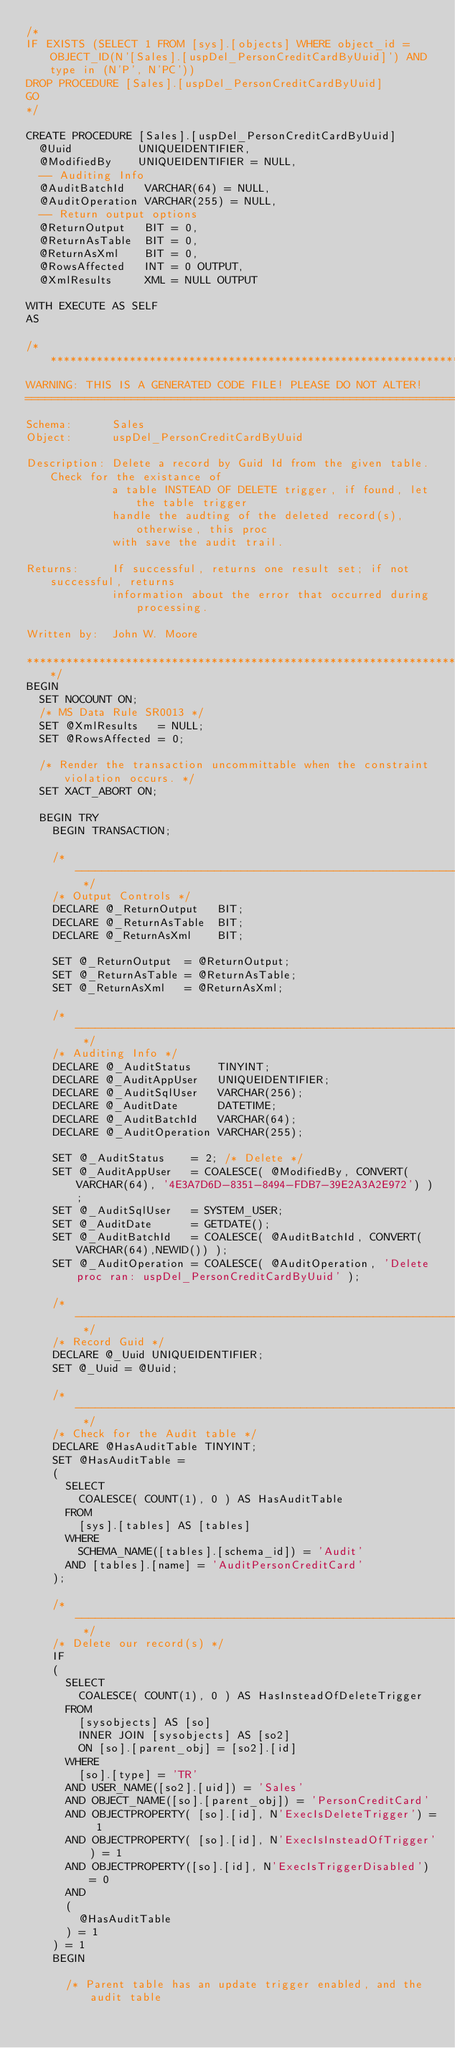<code> <loc_0><loc_0><loc_500><loc_500><_SQL_>/*
IF EXISTS (SELECT 1 FROM [sys].[objects] WHERE object_id = OBJECT_ID(N'[Sales].[uspDel_PersonCreditCardByUuid]') AND type in (N'P', N'PC'))
DROP PROCEDURE [Sales].[uspDel_PersonCreditCardByUuid]
GO
*/

CREATE PROCEDURE [Sales].[uspDel_PersonCreditCardByUuid]
  @Uuid          UNIQUEIDENTIFIER,
  @ModifiedBy    UNIQUEIDENTIFIER = NULL,
  -- Auditing Info
  @AuditBatchId   VARCHAR(64) = NULL,
  @AuditOperation VARCHAR(255) = NULL,
  -- Return output options
  @ReturnOutput   BIT = 0,
  @ReturnAsTable  BIT = 0,
  @ReturnAsXml    BIT = 0,
  @RowsAffected   INT = 0 OUTPUT,
  @XmlResults     XML = NULL OUTPUT

WITH EXECUTE AS SELF
AS

/*******************************************************************************
WARNING: THIS IS A GENERATED CODE FILE! PLEASE DO NOT ALTER!
================================================================================
Schema:      Sales
Object:      uspDel_PersonCreditCardByUuid

Description: Delete a record by Guid Id from the given table. Check for the existance of
             a table INSTEAD OF DELETE trigger, if found, let the table trigger
             handle the audting of the deleted record(s), otherwise, this proc
             with save the audit trail.

Returns:     If successful, returns one result set; if not successful, returns
             information about the error that occurred during processing.

Written by:  John W. Moore

*******************************************************************************/
BEGIN
  SET NOCOUNT ON;
  /* MS Data Rule SR0013 */
  SET @XmlResults   = NULL;
  SET @RowsAffected = 0;

  /* Render the transaction uncommittable when the constraint violation occurs. */
  SET XACT_ABORT ON;

  BEGIN TRY
    BEGIN TRANSACTION;

    /* ------------------------------------------------------------------------- */
    /* Output Controls */
    DECLARE @_ReturnOutput   BIT;
    DECLARE @_ReturnAsTable  BIT;
    DECLARE @_ReturnAsXml    BIT;

    SET @_ReturnOutput  = @ReturnOutput;
    SET @_ReturnAsTable = @ReturnAsTable;
    SET @_ReturnAsXml   = @ReturnAsXml;

    /* ------------------------------------------------------------------------- */
    /* Auditing Info */
    DECLARE @_AuditStatus    TINYINT;
    DECLARE @_AuditAppUser   UNIQUEIDENTIFIER;
    DECLARE @_AuditSqlUser   VARCHAR(256);
    DECLARE @_AuditDate      DATETIME;
    DECLARE @_AuditBatchId   VARCHAR(64);
    DECLARE @_AuditOperation VARCHAR(255);

    SET @_AuditStatus    = 2; /* Delete */
    SET @_AuditAppUser   = COALESCE( @ModifiedBy, CONVERT(VARCHAR(64), '4E3A7D6D-8351-8494-FDB7-39E2A3A2E972') );
    SET @_AuditSqlUser   = SYSTEM_USER;
    SET @_AuditDate      = GETDATE();
    SET @_AuditBatchId   = COALESCE( @AuditBatchId, CONVERT(VARCHAR(64),NEWID()) );
    SET @_AuditOperation = COALESCE( @AuditOperation, 'Delete proc ran: uspDel_PersonCreditCardByUuid' );

    /* ------------------------------------------------------------------------- */
    /* Record Guid */
    DECLARE @_Uuid UNIQUEIDENTIFIER;
    SET @_Uuid = @Uuid;

    /* ------------------------------------------------------------------------- */
    /* Check for the Audit table */
    DECLARE @HasAuditTable TINYINT;
    SET @HasAuditTable =
    (
      SELECT
        COALESCE( COUNT(1), 0 ) AS HasAuditTable
      FROM
        [sys].[tables] AS [tables]
      WHERE
        SCHEMA_NAME([tables].[schema_id]) = 'Audit'
      AND [tables].[name] = 'AuditPersonCreditCard'
    );

    /* ------------------------------------------------------------------------- */
    /* Delete our record(s) */
    IF
    (
      SELECT
        COALESCE( COUNT(1), 0 ) AS HasInsteadOfDeleteTrigger
      FROM
        [sysobjects] AS [so]
        INNER JOIN [sysobjects] AS [so2]
        ON [so].[parent_obj] = [so2].[id]
      WHERE
        [so].[type] = 'TR'
      AND USER_NAME([so2].[uid]) = 'Sales'
      AND OBJECT_NAME([so].[parent_obj]) = 'PersonCreditCard'
      AND OBJECTPROPERTY( [so].[id], N'ExecIsDeleteTrigger') = 1
      AND OBJECTPROPERTY( [so].[id], N'ExecIsInsteadOfTrigger') = 1
      AND OBJECTPROPERTY([so].[id], N'ExecIsTriggerDisabled') = 0
      AND
      (
        @HasAuditTable
      ) = 1
    ) = 1
    BEGIN

      /* Parent table has an update trigger enabled, and the audit table</code> 